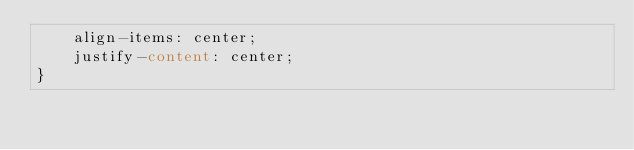<code> <loc_0><loc_0><loc_500><loc_500><_CSS_>    align-items: center;
    justify-content: center;
}</code> 